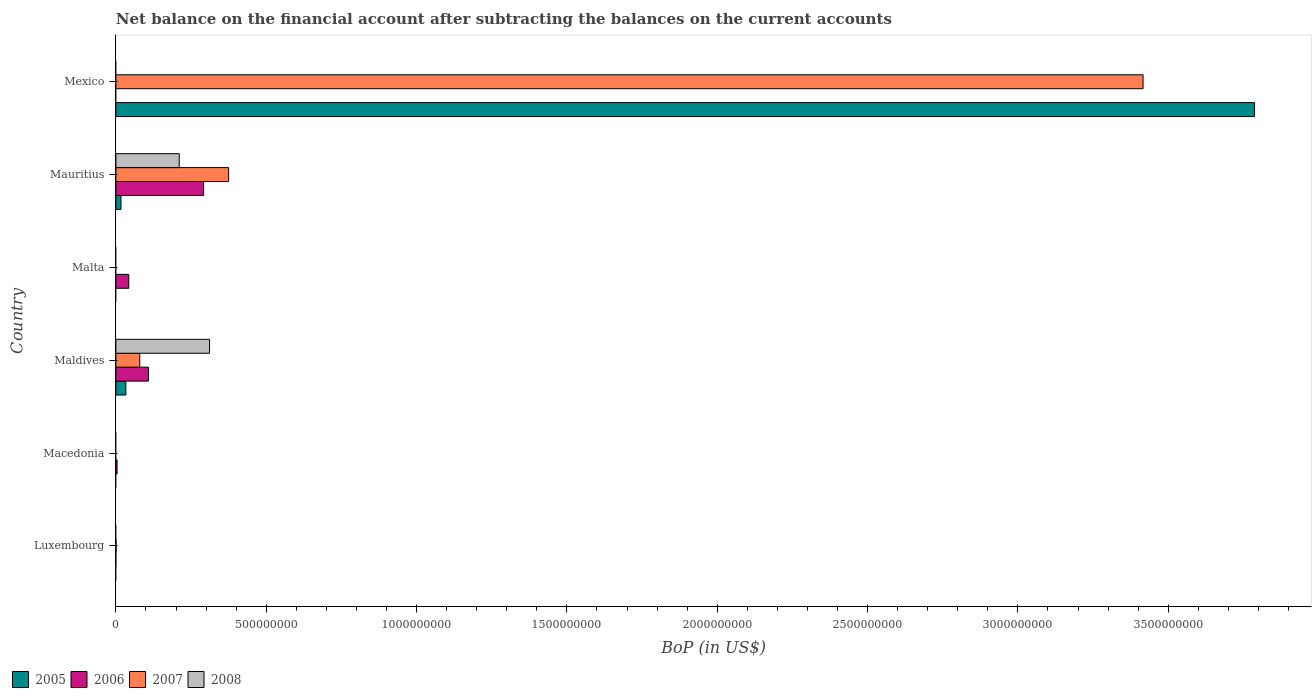Are the number of bars per tick equal to the number of legend labels?
Provide a succinct answer. No. How many bars are there on the 3rd tick from the top?
Keep it short and to the point. 1. How many bars are there on the 4th tick from the bottom?
Make the answer very short. 1. What is the label of the 2nd group of bars from the top?
Give a very brief answer. Mauritius. In how many cases, is the number of bars for a given country not equal to the number of legend labels?
Your response must be concise. 4. What is the Balance of Payments in 2008 in Mauritius?
Make the answer very short. 2.11e+08. Across all countries, what is the maximum Balance of Payments in 2007?
Offer a very short reply. 3.42e+09. In which country was the Balance of Payments in 2006 maximum?
Your answer should be very brief. Mauritius. What is the total Balance of Payments in 2008 in the graph?
Keep it short and to the point. 5.22e+08. What is the difference between the Balance of Payments in 2006 in Macedonia and that in Mauritius?
Your response must be concise. -2.88e+08. What is the difference between the Balance of Payments in 2008 in Maldives and the Balance of Payments in 2005 in Luxembourg?
Ensure brevity in your answer.  3.11e+08. What is the average Balance of Payments in 2008 per country?
Make the answer very short. 8.70e+07. What is the difference between the Balance of Payments in 2007 and Balance of Payments in 2006 in Mauritius?
Your answer should be compact. 8.33e+07. Is the Balance of Payments in 2006 in Maldives less than that in Mauritius?
Your answer should be very brief. Yes. What is the difference between the highest and the second highest Balance of Payments in 2007?
Give a very brief answer. 3.04e+09. What is the difference between the highest and the lowest Balance of Payments in 2008?
Give a very brief answer. 3.11e+08. Is it the case that in every country, the sum of the Balance of Payments in 2005 and Balance of Payments in 2006 is greater than the sum of Balance of Payments in 2008 and Balance of Payments in 2007?
Make the answer very short. No. What is the difference between two consecutive major ticks on the X-axis?
Keep it short and to the point. 5.00e+08. Does the graph contain grids?
Make the answer very short. No. How are the legend labels stacked?
Give a very brief answer. Horizontal. What is the title of the graph?
Offer a terse response. Net balance on the financial account after subtracting the balances on the current accounts. What is the label or title of the X-axis?
Keep it short and to the point. BoP (in US$). What is the BoP (in US$) of 2005 in Luxembourg?
Provide a short and direct response. 0. What is the BoP (in US$) of 2006 in Luxembourg?
Ensure brevity in your answer.  0. What is the BoP (in US$) of 2007 in Luxembourg?
Keep it short and to the point. 4.90e+05. What is the BoP (in US$) of 2005 in Macedonia?
Your response must be concise. 0. What is the BoP (in US$) of 2006 in Macedonia?
Offer a very short reply. 3.96e+06. What is the BoP (in US$) in 2008 in Macedonia?
Your response must be concise. 0. What is the BoP (in US$) in 2005 in Maldives?
Ensure brevity in your answer.  3.32e+07. What is the BoP (in US$) in 2006 in Maldives?
Your answer should be very brief. 1.08e+08. What is the BoP (in US$) of 2007 in Maldives?
Ensure brevity in your answer.  7.95e+07. What is the BoP (in US$) in 2008 in Maldives?
Your answer should be very brief. 3.11e+08. What is the BoP (in US$) of 2006 in Malta?
Ensure brevity in your answer.  4.28e+07. What is the BoP (in US$) in 2007 in Malta?
Your answer should be very brief. 0. What is the BoP (in US$) of 2008 in Malta?
Give a very brief answer. 0. What is the BoP (in US$) in 2005 in Mauritius?
Offer a very short reply. 1.69e+07. What is the BoP (in US$) in 2006 in Mauritius?
Give a very brief answer. 2.92e+08. What is the BoP (in US$) of 2007 in Mauritius?
Offer a terse response. 3.75e+08. What is the BoP (in US$) in 2008 in Mauritius?
Ensure brevity in your answer.  2.11e+08. What is the BoP (in US$) of 2005 in Mexico?
Your response must be concise. 3.79e+09. What is the BoP (in US$) of 2007 in Mexico?
Your response must be concise. 3.42e+09. What is the BoP (in US$) of 2008 in Mexico?
Offer a very short reply. 0. Across all countries, what is the maximum BoP (in US$) in 2005?
Keep it short and to the point. 3.79e+09. Across all countries, what is the maximum BoP (in US$) of 2006?
Make the answer very short. 2.92e+08. Across all countries, what is the maximum BoP (in US$) of 2007?
Give a very brief answer. 3.42e+09. Across all countries, what is the maximum BoP (in US$) of 2008?
Provide a succinct answer. 3.11e+08. Across all countries, what is the minimum BoP (in US$) of 2005?
Provide a succinct answer. 0. Across all countries, what is the minimum BoP (in US$) in 2007?
Offer a terse response. 0. Across all countries, what is the minimum BoP (in US$) of 2008?
Ensure brevity in your answer.  0. What is the total BoP (in US$) of 2005 in the graph?
Your answer should be compact. 3.84e+09. What is the total BoP (in US$) in 2006 in the graph?
Ensure brevity in your answer.  4.47e+08. What is the total BoP (in US$) of 2007 in the graph?
Keep it short and to the point. 3.87e+09. What is the total BoP (in US$) of 2008 in the graph?
Offer a very short reply. 5.22e+08. What is the difference between the BoP (in US$) in 2007 in Luxembourg and that in Maldives?
Provide a succinct answer. -7.90e+07. What is the difference between the BoP (in US$) in 2007 in Luxembourg and that in Mauritius?
Your response must be concise. -3.74e+08. What is the difference between the BoP (in US$) of 2007 in Luxembourg and that in Mexico?
Provide a succinct answer. -3.42e+09. What is the difference between the BoP (in US$) of 2006 in Macedonia and that in Maldives?
Your answer should be compact. -1.04e+08. What is the difference between the BoP (in US$) of 2006 in Macedonia and that in Malta?
Keep it short and to the point. -3.89e+07. What is the difference between the BoP (in US$) of 2006 in Macedonia and that in Mauritius?
Ensure brevity in your answer.  -2.88e+08. What is the difference between the BoP (in US$) in 2006 in Maldives and that in Malta?
Make the answer very short. 6.54e+07. What is the difference between the BoP (in US$) in 2005 in Maldives and that in Mauritius?
Give a very brief answer. 1.62e+07. What is the difference between the BoP (in US$) in 2006 in Maldives and that in Mauritius?
Your answer should be compact. -1.83e+08. What is the difference between the BoP (in US$) in 2007 in Maldives and that in Mauritius?
Provide a short and direct response. -2.95e+08. What is the difference between the BoP (in US$) of 2008 in Maldives and that in Mauritius?
Provide a succinct answer. 1.01e+08. What is the difference between the BoP (in US$) of 2005 in Maldives and that in Mexico?
Provide a short and direct response. -3.75e+09. What is the difference between the BoP (in US$) in 2007 in Maldives and that in Mexico?
Provide a short and direct response. -3.34e+09. What is the difference between the BoP (in US$) in 2006 in Malta and that in Mauritius?
Offer a very short reply. -2.49e+08. What is the difference between the BoP (in US$) in 2005 in Mauritius and that in Mexico?
Make the answer very short. -3.77e+09. What is the difference between the BoP (in US$) of 2007 in Mauritius and that in Mexico?
Offer a very short reply. -3.04e+09. What is the difference between the BoP (in US$) in 2007 in Luxembourg and the BoP (in US$) in 2008 in Maldives?
Your response must be concise. -3.11e+08. What is the difference between the BoP (in US$) in 2007 in Luxembourg and the BoP (in US$) in 2008 in Mauritius?
Your answer should be compact. -2.10e+08. What is the difference between the BoP (in US$) in 2006 in Macedonia and the BoP (in US$) in 2007 in Maldives?
Your response must be concise. -7.55e+07. What is the difference between the BoP (in US$) of 2006 in Macedonia and the BoP (in US$) of 2008 in Maldives?
Ensure brevity in your answer.  -3.08e+08. What is the difference between the BoP (in US$) in 2006 in Macedonia and the BoP (in US$) in 2007 in Mauritius?
Give a very brief answer. -3.71e+08. What is the difference between the BoP (in US$) of 2006 in Macedonia and the BoP (in US$) of 2008 in Mauritius?
Your answer should be compact. -2.07e+08. What is the difference between the BoP (in US$) in 2006 in Macedonia and the BoP (in US$) in 2007 in Mexico?
Your response must be concise. -3.41e+09. What is the difference between the BoP (in US$) of 2005 in Maldives and the BoP (in US$) of 2006 in Malta?
Your response must be concise. -9.65e+06. What is the difference between the BoP (in US$) in 2005 in Maldives and the BoP (in US$) in 2006 in Mauritius?
Provide a succinct answer. -2.58e+08. What is the difference between the BoP (in US$) in 2005 in Maldives and the BoP (in US$) in 2007 in Mauritius?
Keep it short and to the point. -3.42e+08. What is the difference between the BoP (in US$) of 2005 in Maldives and the BoP (in US$) of 2008 in Mauritius?
Offer a terse response. -1.78e+08. What is the difference between the BoP (in US$) in 2006 in Maldives and the BoP (in US$) in 2007 in Mauritius?
Offer a terse response. -2.67e+08. What is the difference between the BoP (in US$) in 2006 in Maldives and the BoP (in US$) in 2008 in Mauritius?
Make the answer very short. -1.02e+08. What is the difference between the BoP (in US$) of 2007 in Maldives and the BoP (in US$) of 2008 in Mauritius?
Your answer should be compact. -1.31e+08. What is the difference between the BoP (in US$) of 2005 in Maldives and the BoP (in US$) of 2007 in Mexico?
Make the answer very short. -3.38e+09. What is the difference between the BoP (in US$) in 2006 in Maldives and the BoP (in US$) in 2007 in Mexico?
Offer a terse response. -3.31e+09. What is the difference between the BoP (in US$) of 2006 in Malta and the BoP (in US$) of 2007 in Mauritius?
Your response must be concise. -3.32e+08. What is the difference between the BoP (in US$) of 2006 in Malta and the BoP (in US$) of 2008 in Mauritius?
Your response must be concise. -1.68e+08. What is the difference between the BoP (in US$) in 2006 in Malta and the BoP (in US$) in 2007 in Mexico?
Provide a short and direct response. -3.37e+09. What is the difference between the BoP (in US$) of 2005 in Mauritius and the BoP (in US$) of 2007 in Mexico?
Make the answer very short. -3.40e+09. What is the difference between the BoP (in US$) of 2006 in Mauritius and the BoP (in US$) of 2007 in Mexico?
Your answer should be very brief. -3.12e+09. What is the average BoP (in US$) of 2005 per country?
Make the answer very short. 6.40e+08. What is the average BoP (in US$) of 2006 per country?
Your response must be concise. 7.44e+07. What is the average BoP (in US$) in 2007 per country?
Provide a short and direct response. 6.45e+08. What is the average BoP (in US$) in 2008 per country?
Your answer should be very brief. 8.70e+07. What is the difference between the BoP (in US$) of 2005 and BoP (in US$) of 2006 in Maldives?
Ensure brevity in your answer.  -7.51e+07. What is the difference between the BoP (in US$) of 2005 and BoP (in US$) of 2007 in Maldives?
Offer a terse response. -4.63e+07. What is the difference between the BoP (in US$) in 2005 and BoP (in US$) in 2008 in Maldives?
Offer a very short reply. -2.78e+08. What is the difference between the BoP (in US$) of 2006 and BoP (in US$) of 2007 in Maldives?
Provide a succinct answer. 2.88e+07. What is the difference between the BoP (in US$) in 2006 and BoP (in US$) in 2008 in Maldives?
Your answer should be very brief. -2.03e+08. What is the difference between the BoP (in US$) of 2007 and BoP (in US$) of 2008 in Maldives?
Make the answer very short. -2.32e+08. What is the difference between the BoP (in US$) of 2005 and BoP (in US$) of 2006 in Mauritius?
Provide a short and direct response. -2.75e+08. What is the difference between the BoP (in US$) of 2005 and BoP (in US$) of 2007 in Mauritius?
Offer a terse response. -3.58e+08. What is the difference between the BoP (in US$) of 2005 and BoP (in US$) of 2008 in Mauritius?
Offer a very short reply. -1.94e+08. What is the difference between the BoP (in US$) of 2006 and BoP (in US$) of 2007 in Mauritius?
Offer a terse response. -8.33e+07. What is the difference between the BoP (in US$) of 2006 and BoP (in US$) of 2008 in Mauritius?
Your response must be concise. 8.10e+07. What is the difference between the BoP (in US$) in 2007 and BoP (in US$) in 2008 in Mauritius?
Give a very brief answer. 1.64e+08. What is the difference between the BoP (in US$) of 2005 and BoP (in US$) of 2007 in Mexico?
Provide a short and direct response. 3.71e+08. What is the ratio of the BoP (in US$) of 2007 in Luxembourg to that in Maldives?
Offer a very short reply. 0.01. What is the ratio of the BoP (in US$) in 2007 in Luxembourg to that in Mauritius?
Offer a very short reply. 0. What is the ratio of the BoP (in US$) of 2006 in Macedonia to that in Maldives?
Give a very brief answer. 0.04. What is the ratio of the BoP (in US$) of 2006 in Macedonia to that in Malta?
Offer a very short reply. 0.09. What is the ratio of the BoP (in US$) of 2006 in Macedonia to that in Mauritius?
Your answer should be very brief. 0.01. What is the ratio of the BoP (in US$) in 2006 in Maldives to that in Malta?
Your response must be concise. 2.53. What is the ratio of the BoP (in US$) of 2005 in Maldives to that in Mauritius?
Provide a short and direct response. 1.96. What is the ratio of the BoP (in US$) in 2006 in Maldives to that in Mauritius?
Offer a very short reply. 0.37. What is the ratio of the BoP (in US$) in 2007 in Maldives to that in Mauritius?
Make the answer very short. 0.21. What is the ratio of the BoP (in US$) in 2008 in Maldives to that in Mauritius?
Make the answer very short. 1.48. What is the ratio of the BoP (in US$) in 2005 in Maldives to that in Mexico?
Offer a very short reply. 0.01. What is the ratio of the BoP (in US$) in 2007 in Maldives to that in Mexico?
Give a very brief answer. 0.02. What is the ratio of the BoP (in US$) in 2006 in Malta to that in Mauritius?
Your answer should be compact. 0.15. What is the ratio of the BoP (in US$) in 2005 in Mauritius to that in Mexico?
Give a very brief answer. 0. What is the ratio of the BoP (in US$) of 2007 in Mauritius to that in Mexico?
Your answer should be very brief. 0.11. What is the difference between the highest and the second highest BoP (in US$) of 2005?
Your answer should be very brief. 3.75e+09. What is the difference between the highest and the second highest BoP (in US$) in 2006?
Keep it short and to the point. 1.83e+08. What is the difference between the highest and the second highest BoP (in US$) in 2007?
Offer a very short reply. 3.04e+09. What is the difference between the highest and the lowest BoP (in US$) of 2005?
Ensure brevity in your answer.  3.79e+09. What is the difference between the highest and the lowest BoP (in US$) of 2006?
Provide a short and direct response. 2.92e+08. What is the difference between the highest and the lowest BoP (in US$) of 2007?
Provide a succinct answer. 3.42e+09. What is the difference between the highest and the lowest BoP (in US$) of 2008?
Provide a short and direct response. 3.11e+08. 